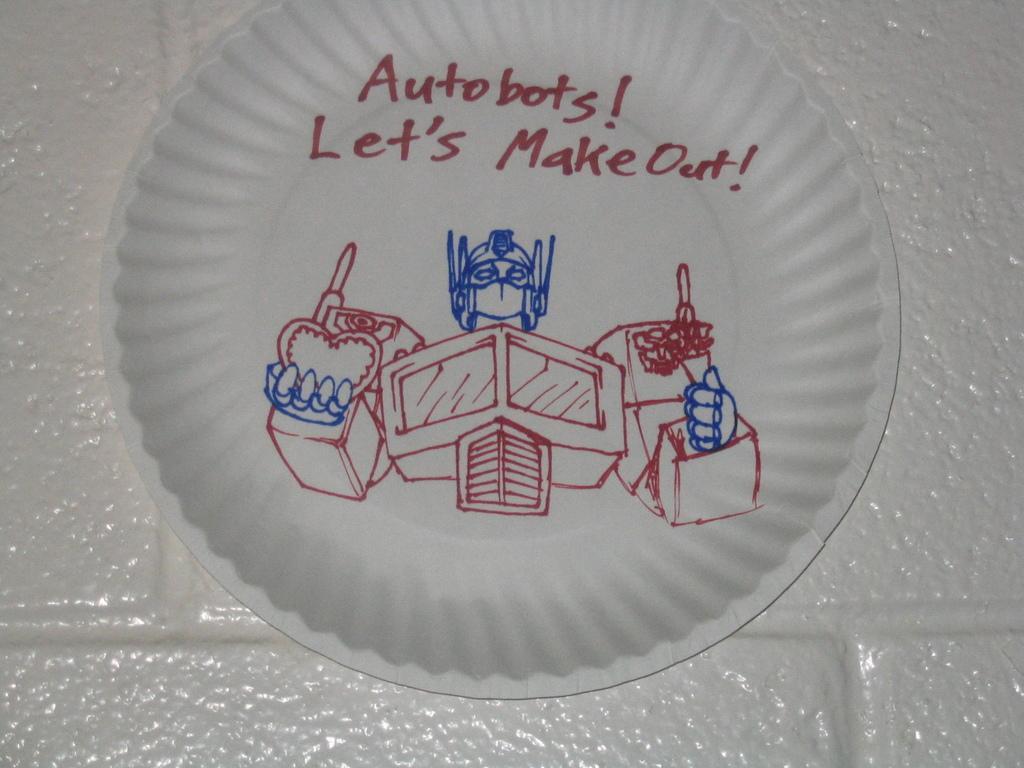How would you summarize this image in a sentence or two? In this picture I can see the text and a diagram on a plate. 